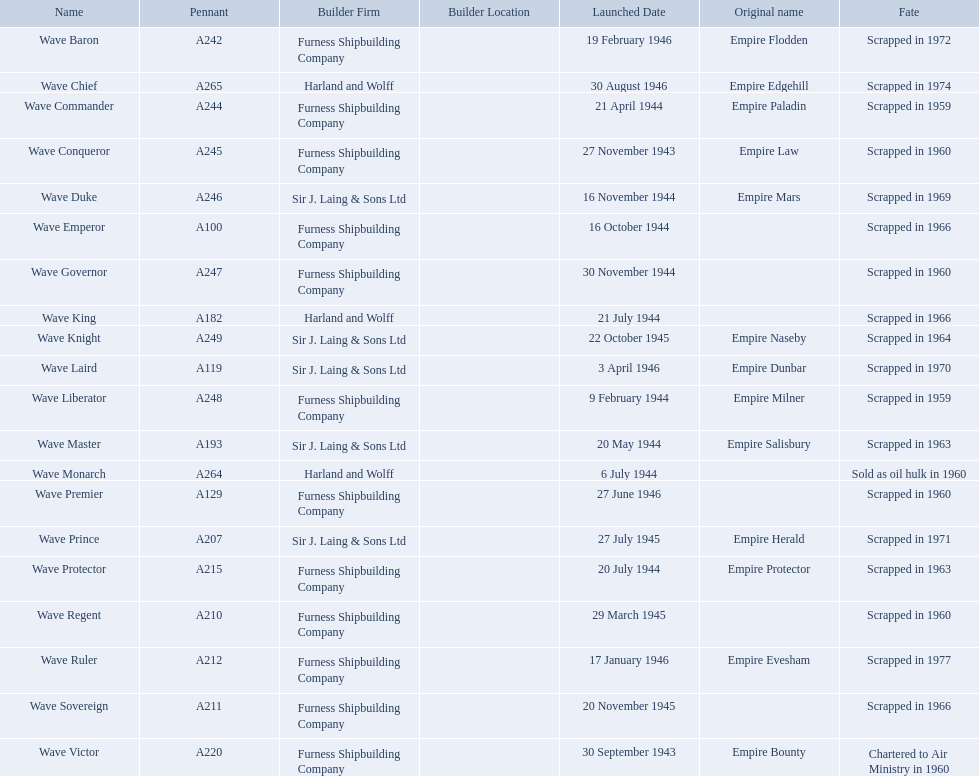Parse the full table. {'header': ['Name', 'Pennant', 'Builder Firm', 'Builder Location', 'Launched Date', 'Original name', 'Fate'], 'rows': [['Wave Baron', 'A242', 'Furness Shipbuilding Company', '', '19 February 1946', 'Empire Flodden', 'Scrapped in 1972'], ['Wave Chief', 'A265', 'Harland and Wolff', '', '30 August 1946', 'Empire Edgehill', 'Scrapped in 1974'], ['Wave Commander', 'A244', 'Furness Shipbuilding Company', '', '21 April 1944', 'Empire Paladin', 'Scrapped in 1959'], ['Wave Conqueror', 'A245', 'Furness Shipbuilding Company', '', '27 November 1943', 'Empire Law', 'Scrapped in 1960'], ['Wave Duke', 'A246', 'Sir J. Laing & Sons Ltd', '', '16 November 1944', 'Empire Mars', 'Scrapped in 1969'], ['Wave Emperor', 'A100', 'Furness Shipbuilding Company', '', '16 October 1944', '', 'Scrapped in 1966'], ['Wave Governor', 'A247', 'Furness Shipbuilding Company', '', '30 November 1944', '', 'Scrapped in 1960'], ['Wave King', 'A182', 'Harland and Wolff', '', '21 July 1944', '', 'Scrapped in 1966'], ['Wave Knight', 'A249', 'Sir J. Laing & Sons Ltd', '', '22 October 1945', 'Empire Naseby', 'Scrapped in 1964'], ['Wave Laird', 'A119', 'Sir J. Laing & Sons Ltd', '', '3 April 1946', 'Empire Dunbar', 'Scrapped in 1970'], ['Wave Liberator', 'A248', 'Furness Shipbuilding Company', '', '9 February 1944', 'Empire Milner', 'Scrapped in 1959'], ['Wave Master', 'A193', 'Sir J. Laing & Sons Ltd', '', '20 May 1944', 'Empire Salisbury', 'Scrapped in 1963'], ['Wave Monarch', 'A264', 'Harland and Wolff', '', '6 July 1944', '', 'Sold as oil hulk in 1960'], ['Wave Premier', 'A129', 'Furness Shipbuilding Company', '', '27 June 1946', '', 'Scrapped in 1960'], ['Wave Prince', 'A207', 'Sir J. Laing & Sons Ltd', '', '27 July 1945', 'Empire Herald', 'Scrapped in 1971'], ['Wave Protector', 'A215', 'Furness Shipbuilding Company', '', '20 July 1944', 'Empire Protector', 'Scrapped in 1963'], ['Wave Regent', 'A210', 'Furness Shipbuilding Company', '', '29 March 1945', '', 'Scrapped in 1960'], ['Wave Ruler', 'A212', 'Furness Shipbuilding Company', '', '17 January 1946', 'Empire Evesham', 'Scrapped in 1977'], ['Wave Sovereign', 'A211', 'Furness Shipbuilding Company', '', '20 November 1945', '', 'Scrapped in 1966'], ['Wave Victor', 'A220', 'Furness Shipbuilding Company', '', '30 September 1943', 'Empire Bounty', 'Chartered to Air Ministry in 1960']]} What date was the wave victor launched? 30 September 1943. What other oiler was launched that same year? Wave Conqueror. 